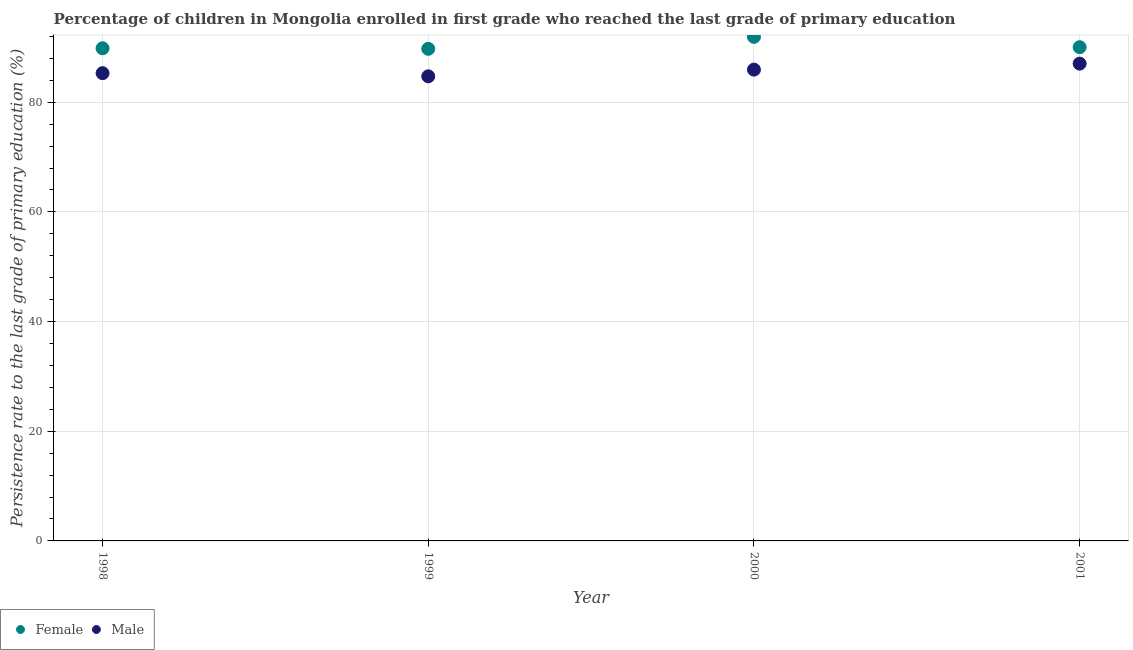What is the persistence rate of male students in 2000?
Keep it short and to the point. 85.95. Across all years, what is the maximum persistence rate of female students?
Ensure brevity in your answer.  91.93. Across all years, what is the minimum persistence rate of male students?
Offer a very short reply. 84.73. In which year was the persistence rate of male students maximum?
Make the answer very short. 2001. In which year was the persistence rate of female students minimum?
Give a very brief answer. 1999. What is the total persistence rate of male students in the graph?
Ensure brevity in your answer.  343.03. What is the difference between the persistence rate of male students in 1998 and that in 2000?
Keep it short and to the point. -0.65. What is the difference between the persistence rate of female students in 1998 and the persistence rate of male students in 2000?
Your answer should be very brief. 3.89. What is the average persistence rate of male students per year?
Offer a very short reply. 85.76. In the year 1999, what is the difference between the persistence rate of male students and persistence rate of female students?
Make the answer very short. -5.02. In how many years, is the persistence rate of female students greater than 64 %?
Your answer should be very brief. 4. What is the ratio of the persistence rate of male students in 1998 to that in 1999?
Provide a short and direct response. 1.01. Is the difference between the persistence rate of male students in 2000 and 2001 greater than the difference between the persistence rate of female students in 2000 and 2001?
Provide a succinct answer. No. What is the difference between the highest and the second highest persistence rate of male students?
Keep it short and to the point. 1.09. What is the difference between the highest and the lowest persistence rate of female students?
Your answer should be very brief. 2.18. In how many years, is the persistence rate of female students greater than the average persistence rate of female students taken over all years?
Your answer should be very brief. 1. Is the sum of the persistence rate of male students in 1998 and 2000 greater than the maximum persistence rate of female students across all years?
Your answer should be compact. Yes. Does the persistence rate of male students monotonically increase over the years?
Make the answer very short. No. Is the persistence rate of male students strictly greater than the persistence rate of female students over the years?
Offer a very short reply. No. Are the values on the major ticks of Y-axis written in scientific E-notation?
Your answer should be compact. No. Where does the legend appear in the graph?
Provide a succinct answer. Bottom left. How many legend labels are there?
Your response must be concise. 2. What is the title of the graph?
Ensure brevity in your answer.  Percentage of children in Mongolia enrolled in first grade who reached the last grade of primary education. What is the label or title of the Y-axis?
Your response must be concise. Persistence rate to the last grade of primary education (%). What is the Persistence rate to the last grade of primary education (%) of Female in 1998?
Offer a very short reply. 89.84. What is the Persistence rate to the last grade of primary education (%) of Male in 1998?
Offer a very short reply. 85.3. What is the Persistence rate to the last grade of primary education (%) of Female in 1999?
Ensure brevity in your answer.  89.75. What is the Persistence rate to the last grade of primary education (%) in Male in 1999?
Keep it short and to the point. 84.73. What is the Persistence rate to the last grade of primary education (%) of Female in 2000?
Ensure brevity in your answer.  91.93. What is the Persistence rate to the last grade of primary education (%) in Male in 2000?
Make the answer very short. 85.95. What is the Persistence rate to the last grade of primary education (%) in Female in 2001?
Ensure brevity in your answer.  90.04. What is the Persistence rate to the last grade of primary education (%) in Male in 2001?
Make the answer very short. 87.04. Across all years, what is the maximum Persistence rate to the last grade of primary education (%) of Female?
Provide a short and direct response. 91.93. Across all years, what is the maximum Persistence rate to the last grade of primary education (%) of Male?
Your response must be concise. 87.04. Across all years, what is the minimum Persistence rate to the last grade of primary education (%) in Female?
Make the answer very short. 89.75. Across all years, what is the minimum Persistence rate to the last grade of primary education (%) in Male?
Offer a terse response. 84.73. What is the total Persistence rate to the last grade of primary education (%) in Female in the graph?
Your response must be concise. 361.56. What is the total Persistence rate to the last grade of primary education (%) in Male in the graph?
Your response must be concise. 343.03. What is the difference between the Persistence rate to the last grade of primary education (%) in Female in 1998 and that in 1999?
Your answer should be compact. 0.1. What is the difference between the Persistence rate to the last grade of primary education (%) of Male in 1998 and that in 1999?
Your answer should be very brief. 0.57. What is the difference between the Persistence rate to the last grade of primary education (%) in Female in 1998 and that in 2000?
Give a very brief answer. -2.08. What is the difference between the Persistence rate to the last grade of primary education (%) of Male in 1998 and that in 2000?
Offer a terse response. -0.65. What is the difference between the Persistence rate to the last grade of primary education (%) of Female in 1998 and that in 2001?
Your answer should be very brief. -0.2. What is the difference between the Persistence rate to the last grade of primary education (%) in Male in 1998 and that in 2001?
Keep it short and to the point. -1.74. What is the difference between the Persistence rate to the last grade of primary education (%) in Female in 1999 and that in 2000?
Offer a very short reply. -2.18. What is the difference between the Persistence rate to the last grade of primary education (%) in Male in 1999 and that in 2000?
Your response must be concise. -1.22. What is the difference between the Persistence rate to the last grade of primary education (%) in Female in 1999 and that in 2001?
Make the answer very short. -0.29. What is the difference between the Persistence rate to the last grade of primary education (%) in Male in 1999 and that in 2001?
Offer a terse response. -2.31. What is the difference between the Persistence rate to the last grade of primary education (%) of Female in 2000 and that in 2001?
Offer a very short reply. 1.89. What is the difference between the Persistence rate to the last grade of primary education (%) of Male in 2000 and that in 2001?
Offer a terse response. -1.09. What is the difference between the Persistence rate to the last grade of primary education (%) of Female in 1998 and the Persistence rate to the last grade of primary education (%) of Male in 1999?
Make the answer very short. 5.11. What is the difference between the Persistence rate to the last grade of primary education (%) of Female in 1998 and the Persistence rate to the last grade of primary education (%) of Male in 2000?
Your response must be concise. 3.89. What is the difference between the Persistence rate to the last grade of primary education (%) in Female in 1998 and the Persistence rate to the last grade of primary education (%) in Male in 2001?
Your answer should be very brief. 2.8. What is the difference between the Persistence rate to the last grade of primary education (%) in Female in 1999 and the Persistence rate to the last grade of primary education (%) in Male in 2000?
Give a very brief answer. 3.79. What is the difference between the Persistence rate to the last grade of primary education (%) of Female in 1999 and the Persistence rate to the last grade of primary education (%) of Male in 2001?
Provide a short and direct response. 2.7. What is the difference between the Persistence rate to the last grade of primary education (%) in Female in 2000 and the Persistence rate to the last grade of primary education (%) in Male in 2001?
Your answer should be compact. 4.88. What is the average Persistence rate to the last grade of primary education (%) of Female per year?
Your answer should be very brief. 90.39. What is the average Persistence rate to the last grade of primary education (%) in Male per year?
Give a very brief answer. 85.76. In the year 1998, what is the difference between the Persistence rate to the last grade of primary education (%) of Female and Persistence rate to the last grade of primary education (%) of Male?
Offer a terse response. 4.54. In the year 1999, what is the difference between the Persistence rate to the last grade of primary education (%) in Female and Persistence rate to the last grade of primary education (%) in Male?
Ensure brevity in your answer.  5.02. In the year 2000, what is the difference between the Persistence rate to the last grade of primary education (%) in Female and Persistence rate to the last grade of primary education (%) in Male?
Your answer should be compact. 5.98. In the year 2001, what is the difference between the Persistence rate to the last grade of primary education (%) of Female and Persistence rate to the last grade of primary education (%) of Male?
Offer a terse response. 3. What is the ratio of the Persistence rate to the last grade of primary education (%) of Female in 1998 to that in 1999?
Offer a very short reply. 1. What is the ratio of the Persistence rate to the last grade of primary education (%) in Male in 1998 to that in 1999?
Offer a very short reply. 1.01. What is the ratio of the Persistence rate to the last grade of primary education (%) of Female in 1998 to that in 2000?
Your response must be concise. 0.98. What is the ratio of the Persistence rate to the last grade of primary education (%) of Female in 1999 to that in 2000?
Your answer should be compact. 0.98. What is the ratio of the Persistence rate to the last grade of primary education (%) of Male in 1999 to that in 2000?
Provide a short and direct response. 0.99. What is the ratio of the Persistence rate to the last grade of primary education (%) in Female in 1999 to that in 2001?
Your response must be concise. 1. What is the ratio of the Persistence rate to the last grade of primary education (%) of Male in 1999 to that in 2001?
Keep it short and to the point. 0.97. What is the ratio of the Persistence rate to the last grade of primary education (%) of Male in 2000 to that in 2001?
Your answer should be compact. 0.99. What is the difference between the highest and the second highest Persistence rate to the last grade of primary education (%) in Female?
Your answer should be compact. 1.89. What is the difference between the highest and the second highest Persistence rate to the last grade of primary education (%) in Male?
Give a very brief answer. 1.09. What is the difference between the highest and the lowest Persistence rate to the last grade of primary education (%) in Female?
Keep it short and to the point. 2.18. What is the difference between the highest and the lowest Persistence rate to the last grade of primary education (%) in Male?
Provide a succinct answer. 2.31. 